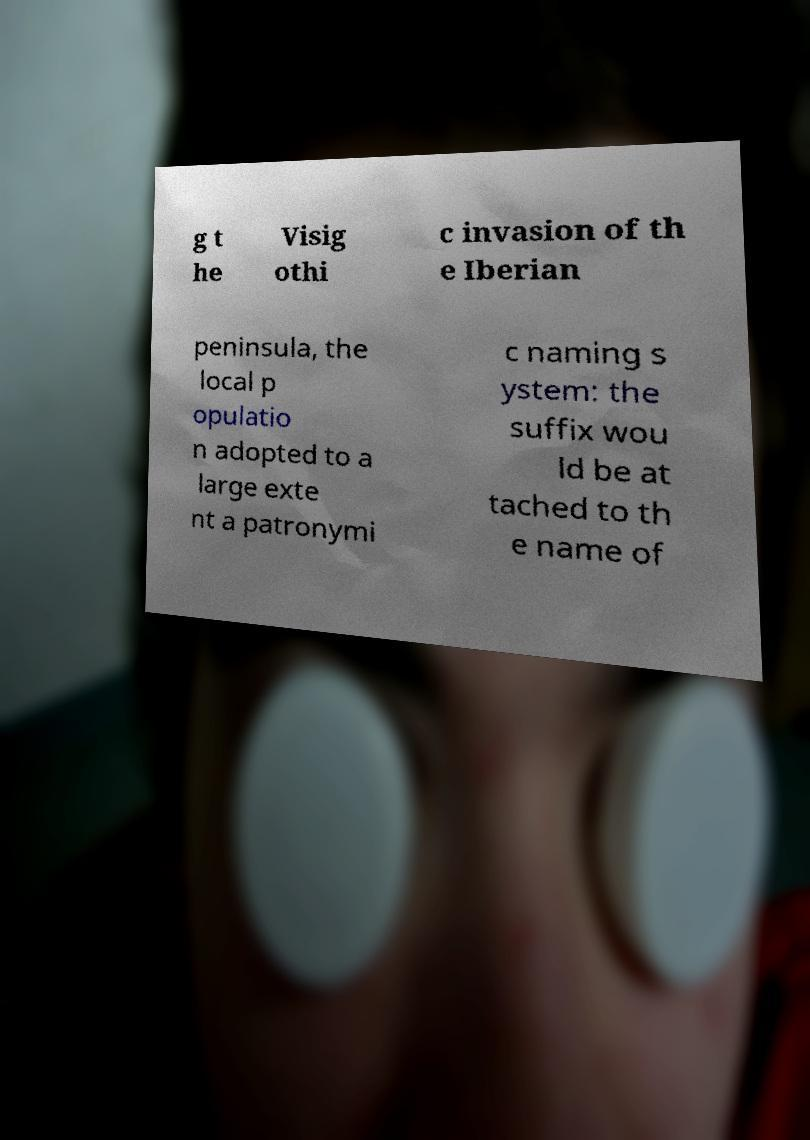Please read and relay the text visible in this image. What does it say? g t he Visig othi c invasion of th e Iberian peninsula, the local p opulatio n adopted to a large exte nt a patronymi c naming s ystem: the suffix wou ld be at tached to th e name of 